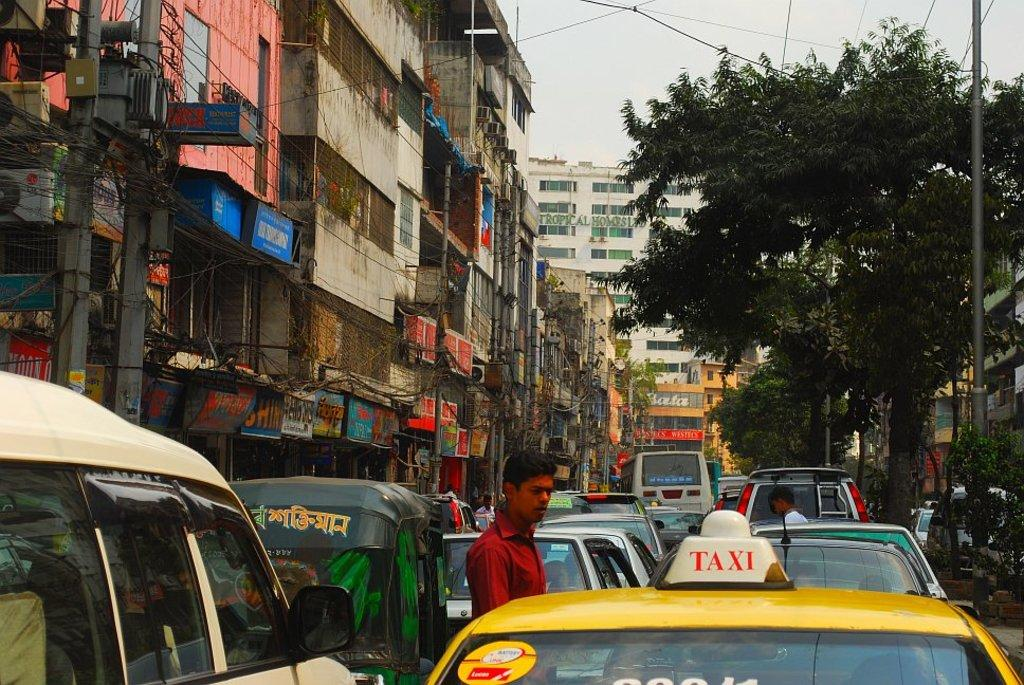<image>
Offer a succinct explanation of the picture presented. A street filled with various cars including a taxi in the foreground 